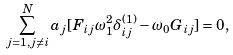Convert formula to latex. <formula><loc_0><loc_0><loc_500><loc_500>\sum _ { j = 1 , j \neq i } ^ { N } a _ { j } [ F _ { i j } \omega _ { 1 } ^ { 2 } \delta ^ { ( 1 ) } _ { i j } - \omega _ { 0 } G _ { i j } ] = 0 ,</formula> 